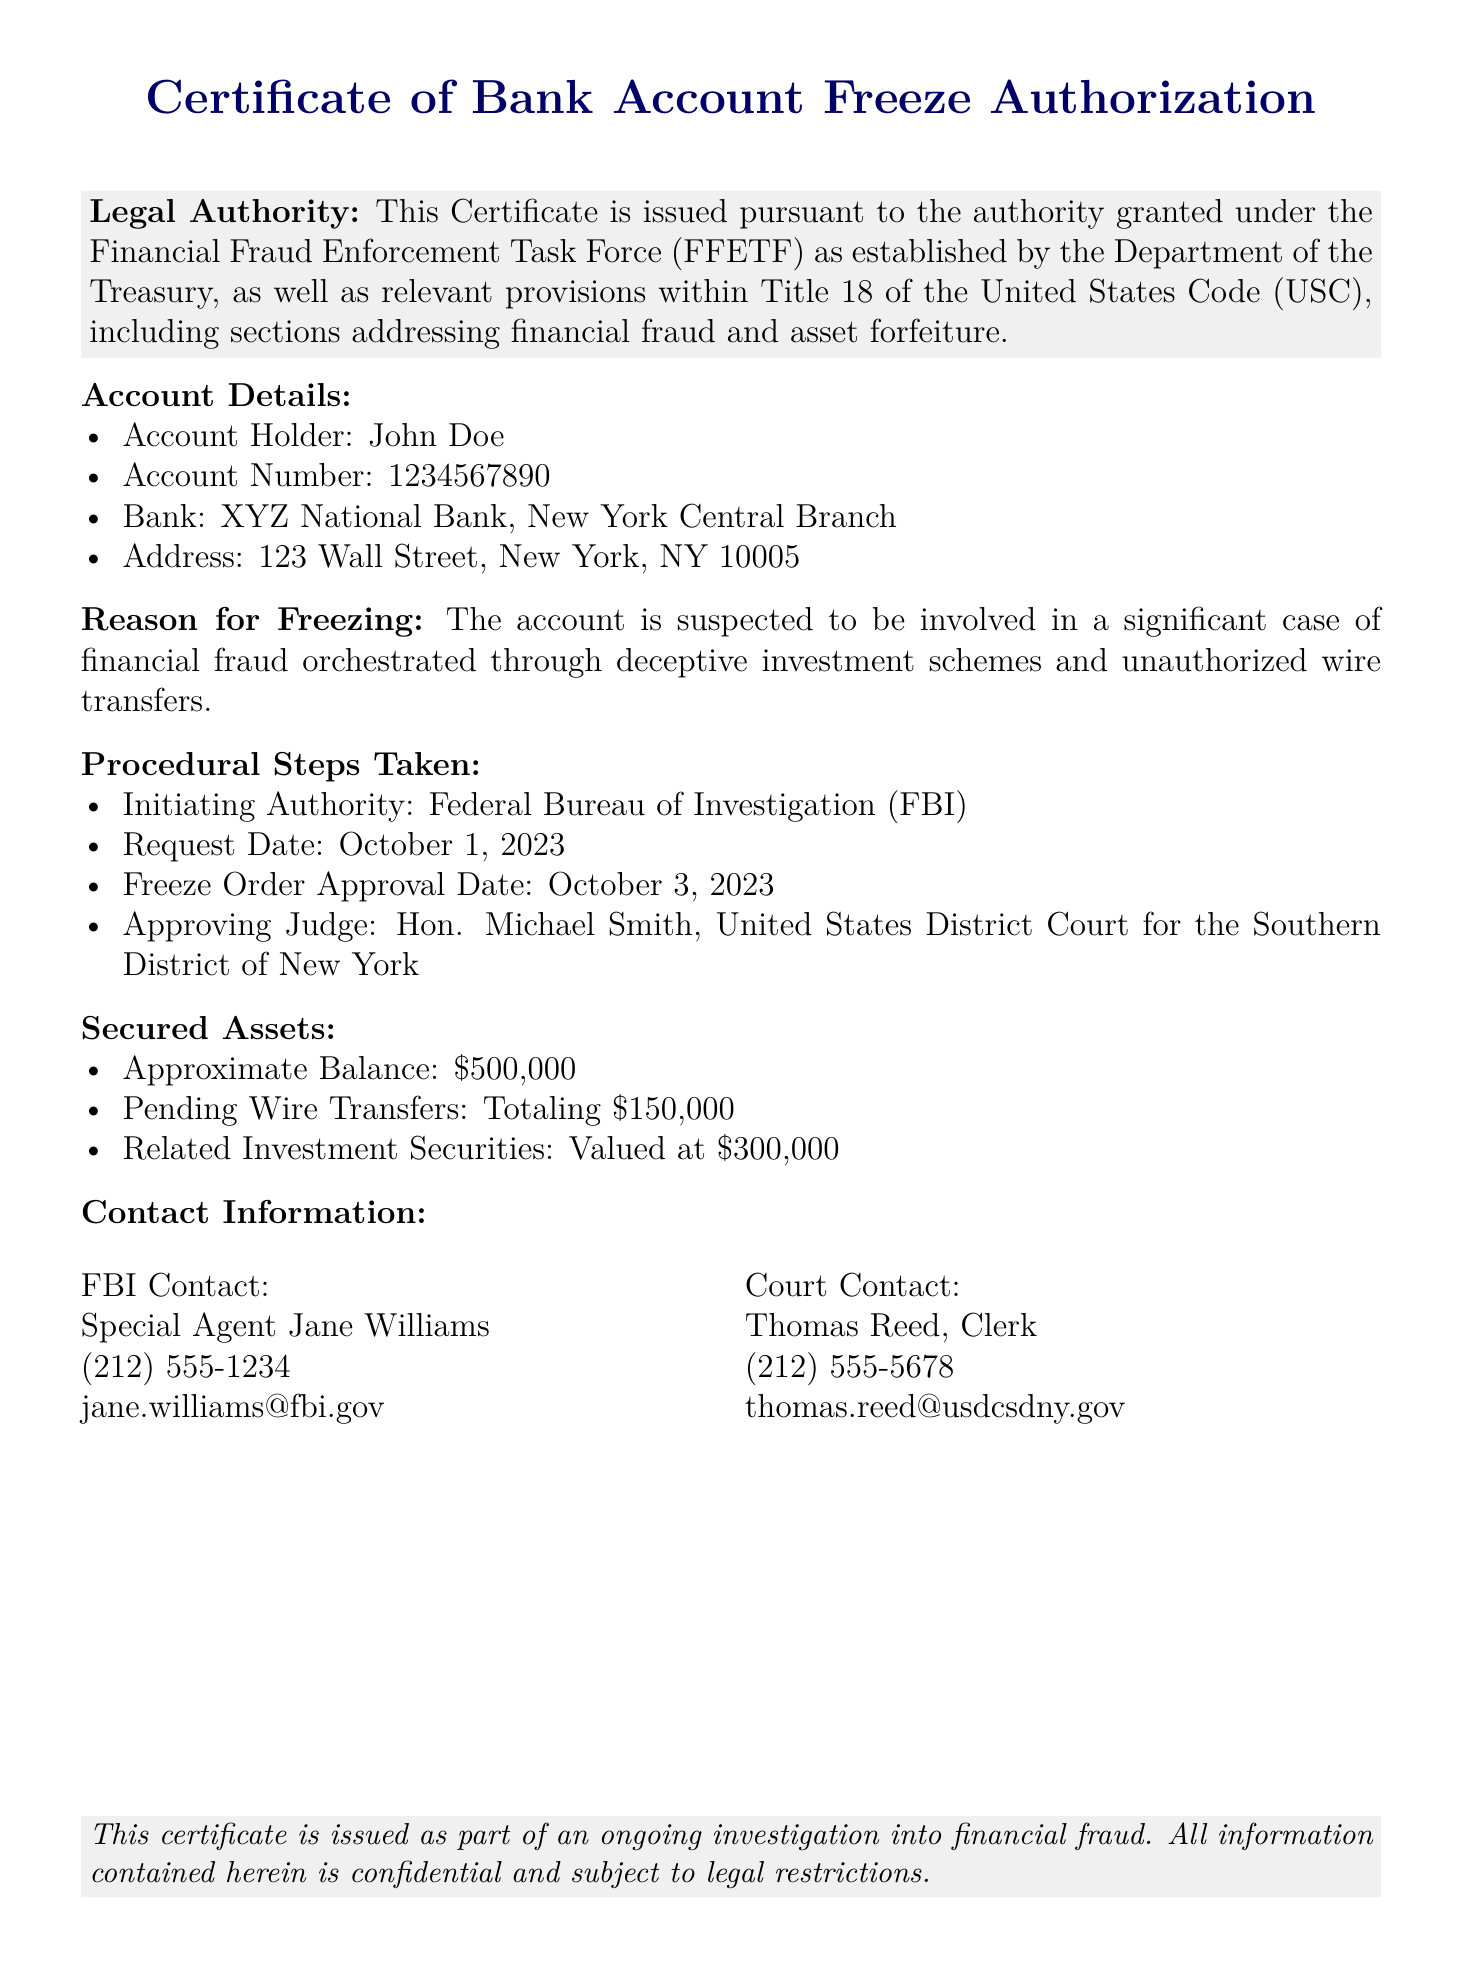What is the name of the account holder? The name of the account holder is explicitly stated in the document under Account Details.
Answer: John Doe What is the account number? The account number is clearly provided in the Account Details section of the document.
Answer: 1234567890 Which authority issued this certificate? The issuing authority is identified in the Legal Authority section of the document.
Answer: Financial Fraud Enforcement Task Force What is the date of the freeze order approval? This date is specified in the Procedural Steps Taken section of the document.
Answer: October 3, 2023 Who approved the freeze order? The name of the approving judge is mentioned along with their title in the document.
Answer: Hon. Michael Smith What approximate balance is secured in the account? The approximate balance is listed in the Secured Assets section.
Answer: $500,000 What is the total amount of pending wire transfers? The total pending wire transfers is provided in the Secured Assets section of the document.
Answer: $150,000 What type of fraud is associated with the account? The reason for freezing the account outlines the type of fraud involved.
Answer: Financial fraud What was the request date for the freeze order? This date is mentioned in the Procedural Steps Taken section of the document.
Answer: October 1, 2023 